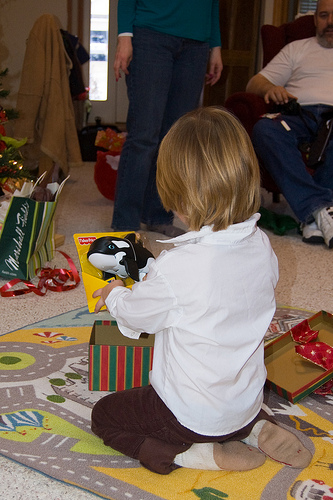<image>
Is the box behind the child? No. The box is not behind the child. From this viewpoint, the box appears to be positioned elsewhere in the scene. Is there a jacket in front of the toy? Yes. The jacket is positioned in front of the toy, appearing closer to the camera viewpoint. 